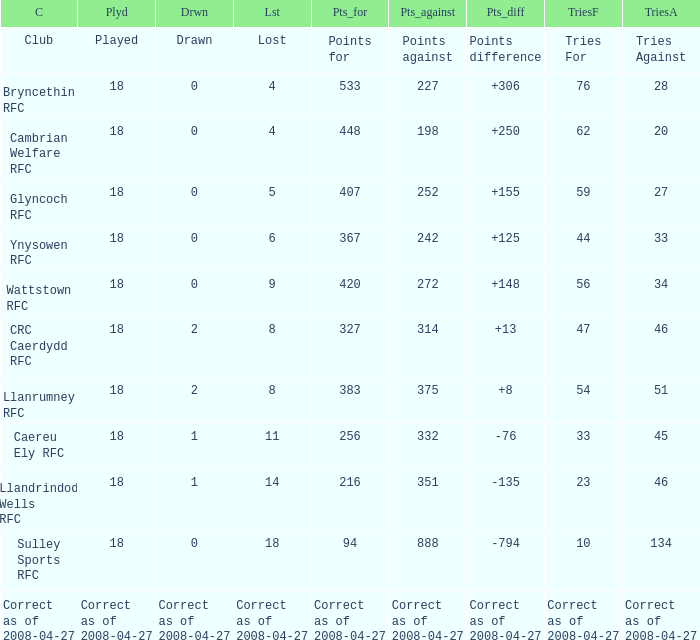What is the value for the item "Lost" when the value "Tries" is 47? 8.0. 